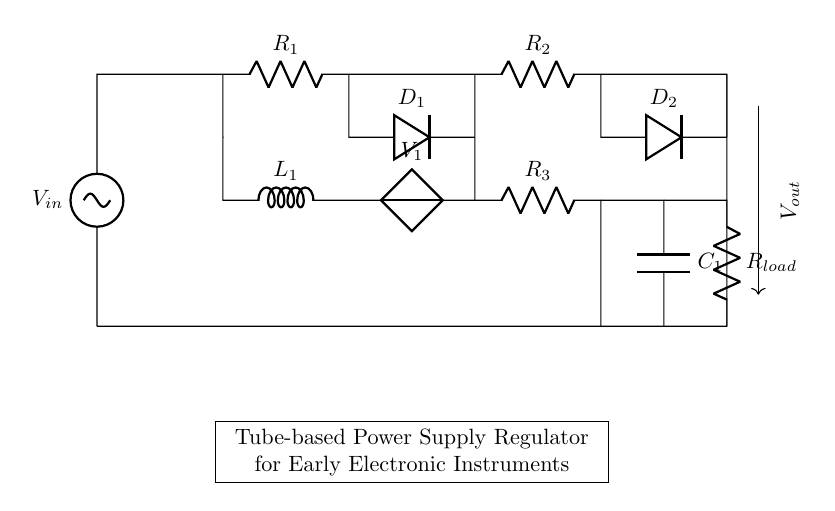What is the input voltage of this circuit? The input voltage can be identified as V_in in the circuit diagram. It is explicitly labeled as the source at the top left.
Answer: V_in What are the two types of components depicted in this regulator circuit? The circuit diagram shows passive components (like resistors, inductors, and capacitors) and active components (like diodes and the voltage source). This distinction is based on their functionality in the circuit.
Answer: Passive and active How many resistors are present in this circuit? By counting the components labeled R while referring to the diagram, there are four resistors labeled as R1, R2, R3, and R_load.
Answer: Four What is the role of the diodes in this regulator circuit? The diodes D1 and D2 allow current to flow in only one direction, preventing reverse current that can damage other components, especially in power supply applications. This is crucial for ensuring the integrity of the voltage supplied to the load.
Answer: Rectification What would likely happen if the capacitor C1 were removed from the circuit? Removing C1 would likely lead to voltage fluctuations due to a lack of smoothing, which can cause instability in the power supply. The capacitor acts as a filter, stabilizing the output voltage by storing charge and releasing it when needed, especially under load changes.
Answer: Voltage fluctuations What does L1 represent in this diagram, and what is its purpose? L1 represents an inductor, which is used to filter current and provide reactive power to the circuit. Its function is to oppose changes in current, which helps to stabilize the supply represented by V1.
Answer: Inductor What component connects to the output labeled V_out? The output labeled V_out connects to the load resistor R_load, which represents the component that utilizes the regulated power output of the circuit. This shows how the circuit is intended to deliver power to an external device.
Answer: R_load 